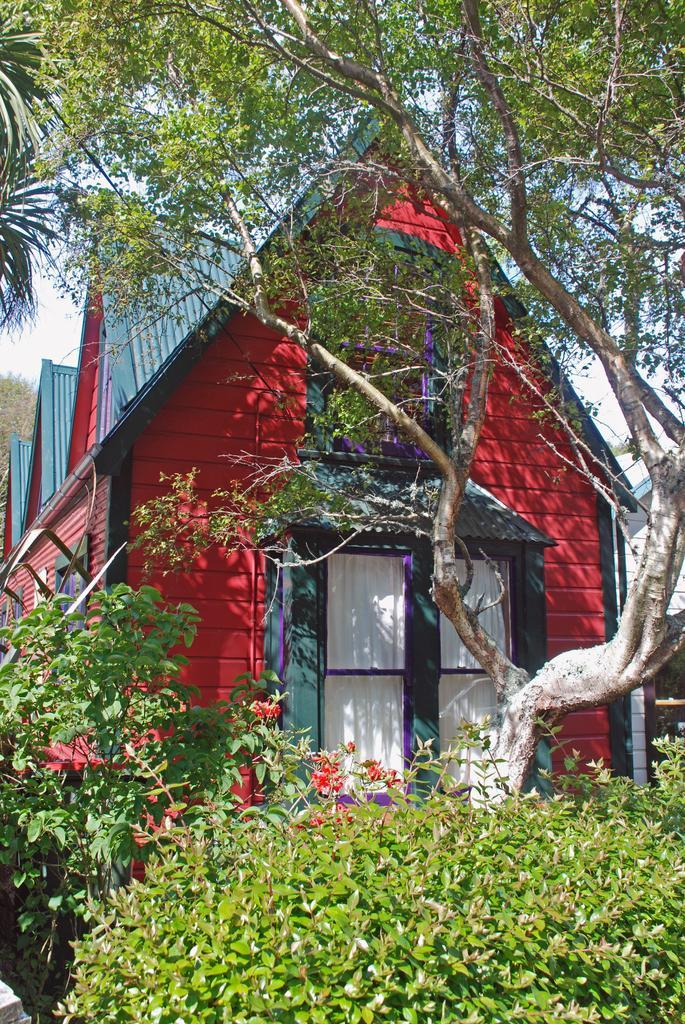Describe this image in one or two sentences. At the bottom of the picture, we see plants. Behind that, there is a tree and behind that, there are red color buildings with blue color roof. 